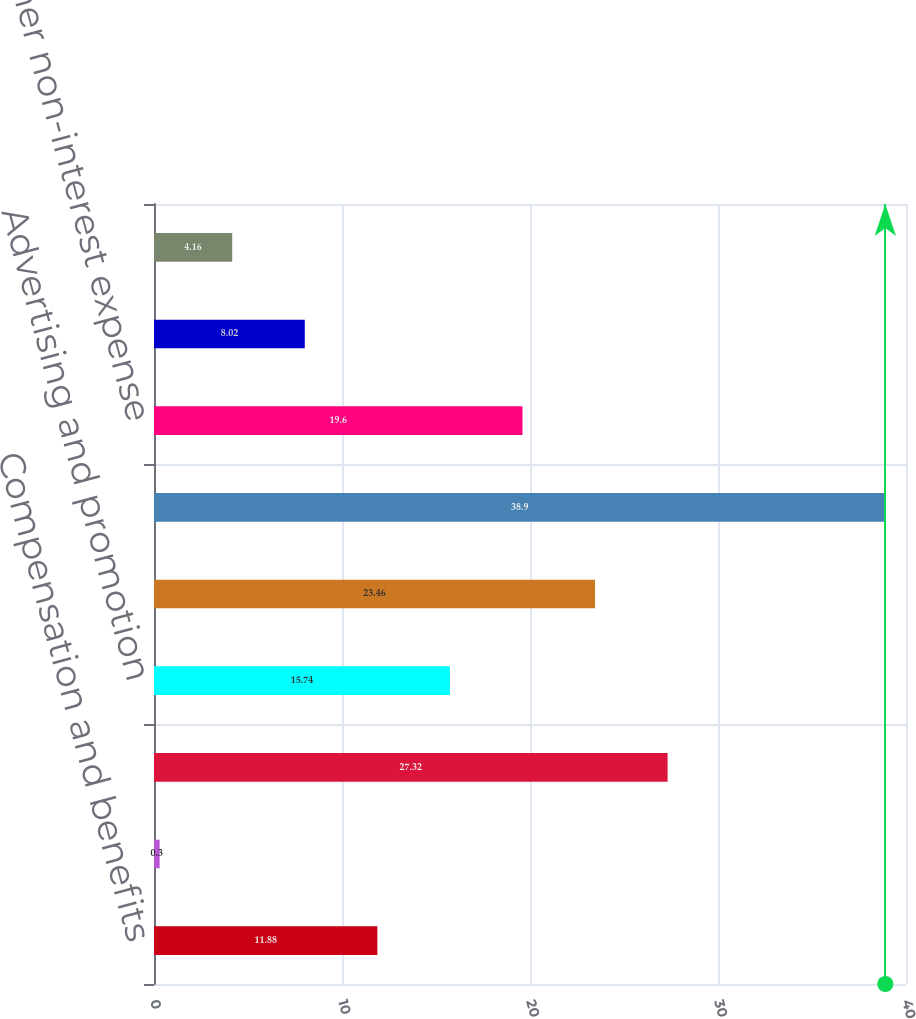Convert chart to OTSL. <chart><loc_0><loc_0><loc_500><loc_500><bar_chart><fcel>Compensation and benefits<fcel>Occupancy and equipment<fcel>Professional and outside<fcel>Advertising and promotion<fcel>Stationery printing and<fcel>Amortization of other<fcel>Other non-interest expense<fcel>Total<fcel>Total non-interest expense<nl><fcel>11.88<fcel>0.3<fcel>27.32<fcel>15.74<fcel>23.46<fcel>38.9<fcel>19.6<fcel>8.02<fcel>4.16<nl></chart> 